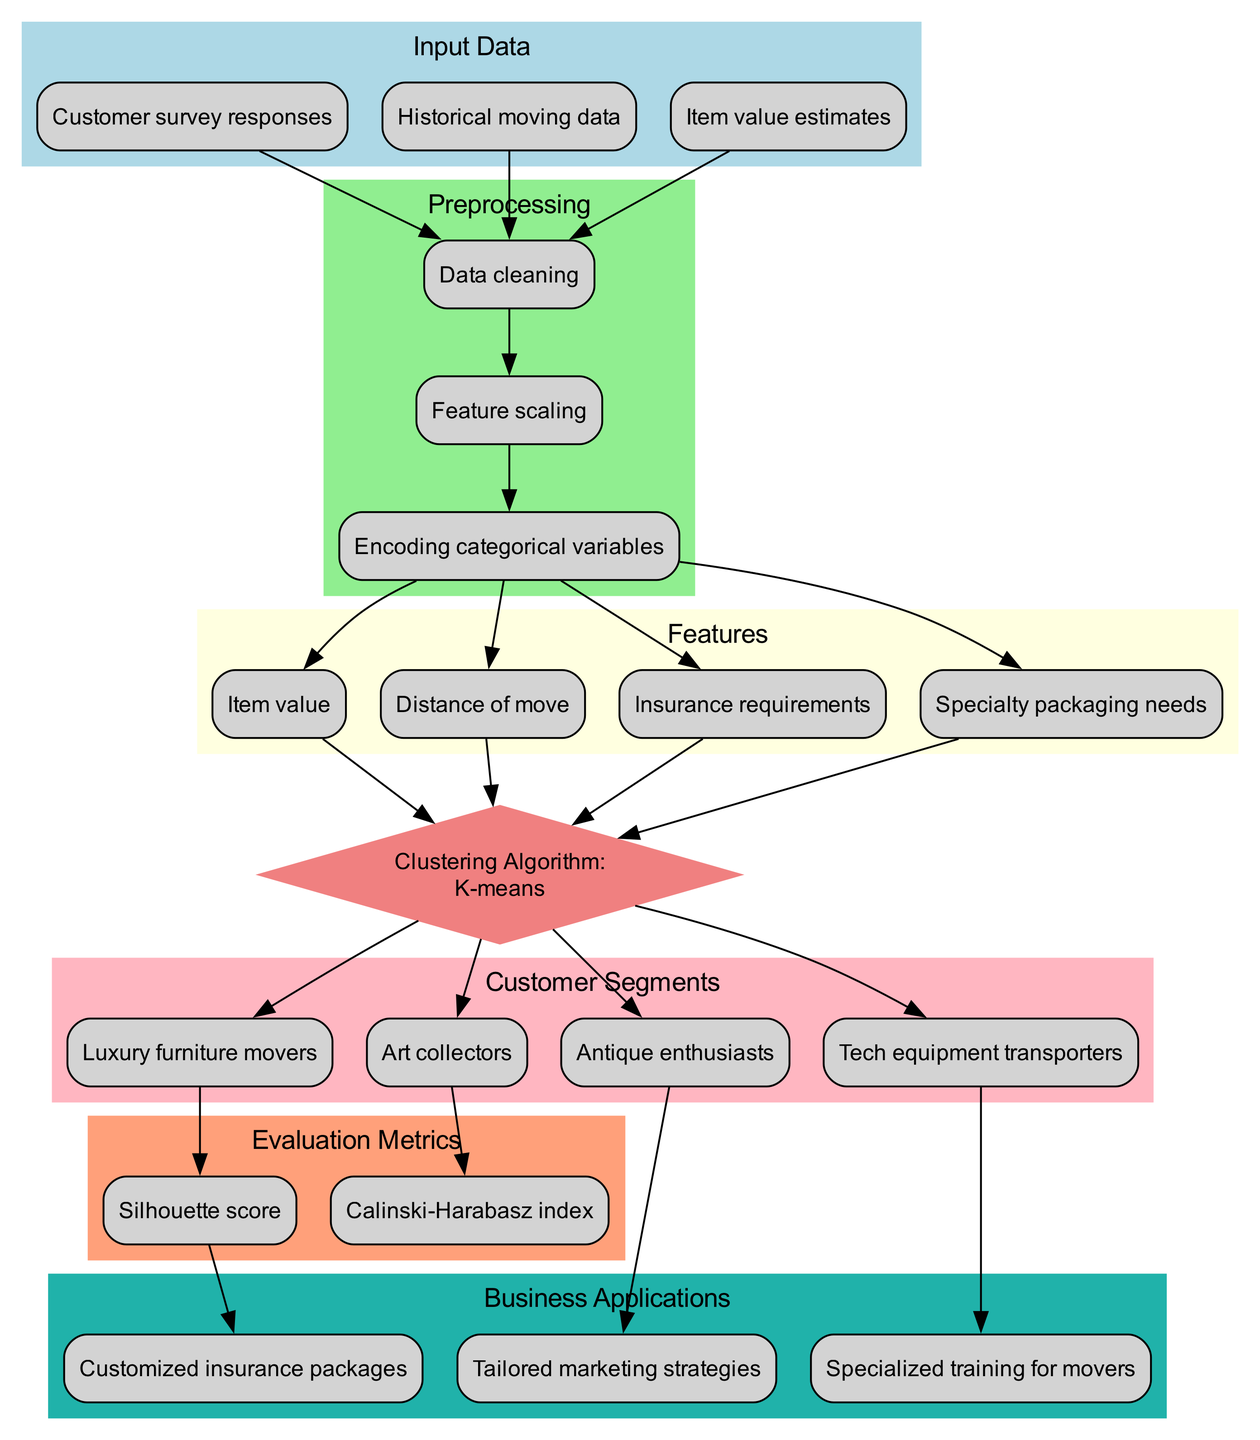What is the clustering algorithm used in this diagram? The diagram explicitly states that the clustering algorithm used is K-means, which is listed in the Clustering Algorithm section.
Answer: K-means How many clusters are identified in this diagram? By counting the entries in the Customer Segments section, we find there are four distinct clusters: Luxury furniture movers, Art collectors, Antique enthusiasts, Tech equipment transporters.
Answer: Four Which feature is directly related to 'Insurance requirements'? In the flow of the diagram, 'Insurance requirements' connects directly to the Clustering Algorithm node, indicating it is one of the features used for clustering.
Answer: Clustering Algorithm What preprocessing step follows 'Data cleaning'? From the preprocessing section, 'Feature scaling' is the step that follows 'Data cleaning'. This is shown as a directed edge from 'Data cleaning' to 'Feature scaling'.
Answer: Feature scaling Which customer segment relates to the 'Tailored marketing strategies'? Looking at the connections, 'Antique enthusiasts' is the customer segment that has a direct edge leading to 'Tailored marketing strategies' in the diagram.
Answer: Antique enthusiasts What are two evaluation metrics listed in the diagram? The diagram includes 'Silhouette score' and 'Calinski-Harabasz index' as evaluation metrics under the Evaluation Metrics section.
Answer: Silhouette score, Calinski-Harabasz index Which feature is essential for providing 'Customized insurance packages'? The edge connects 'Silhouette score' to 'Customized insurance packages', which indicates that the clustering evaluation influences the creation of tailored insurance strategies.
Answer: Silhouette score What type of business application is indicated for 'Art collectors'? In the diagram, 'Art collectors' connects to 'Specialized training for movers', indicating this is the business application tied to that segment.
Answer: Specialized training for movers How does 'Historical moving data' relate to the data flow? 'Historical moving data' has a direct edge to 'Data cleaning', indicating it is part of the input data that needs to be cleaned before further processing.
Answer: Data cleaning 